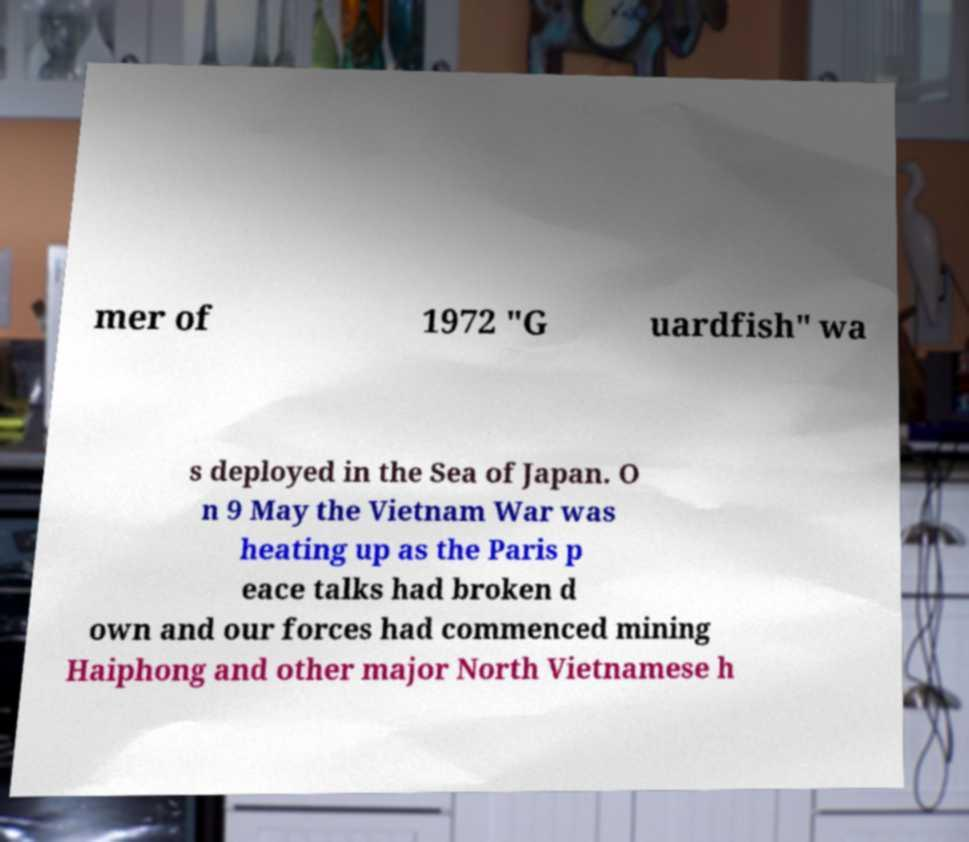There's text embedded in this image that I need extracted. Can you transcribe it verbatim? mer of 1972 "G uardfish" wa s deployed in the Sea of Japan. O n 9 May the Vietnam War was heating up as the Paris p eace talks had broken d own and our forces had commenced mining Haiphong and other major North Vietnamese h 